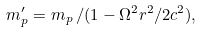Convert formula to latex. <formula><loc_0><loc_0><loc_500><loc_500>m ^ { \prime } _ { p } = m _ { p } \, / ( 1 - \Omega ^ { 2 } r ^ { 2 } / 2 c ^ { 2 } ) ,</formula> 